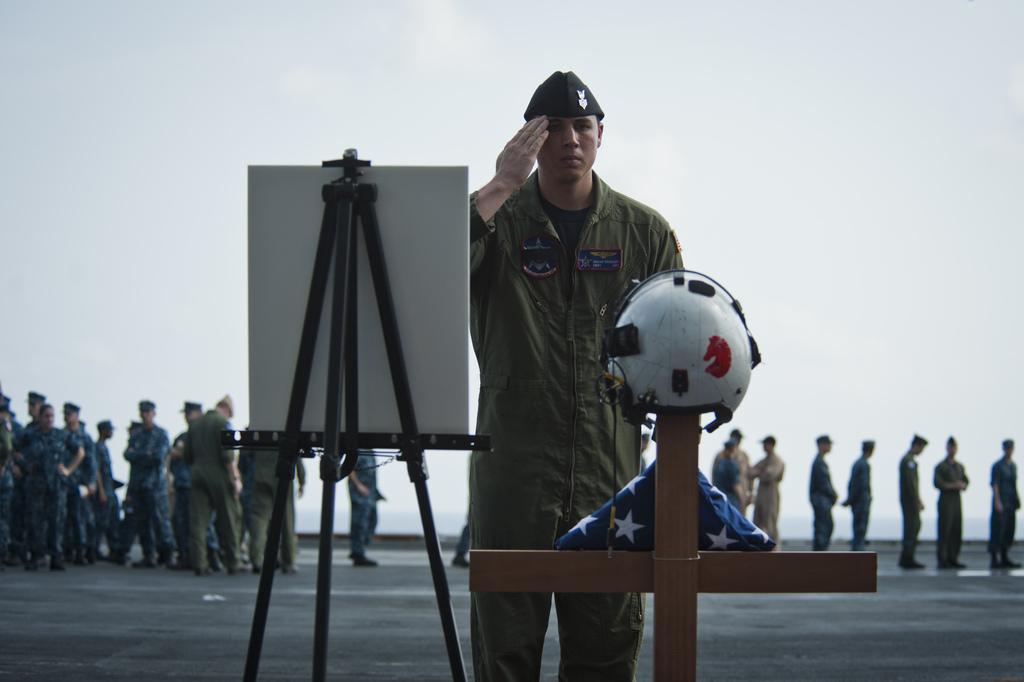In one or two sentences, can you explain what this image depicts? In the center of the image, we can see a person wearing uniform and a cap and there is a board, a stand and we can see a helmet, cloth and a cross. In the background, there are some other people and are wearing uniforms and standing. At the bottom, there is a road and at the top, there is sky. 